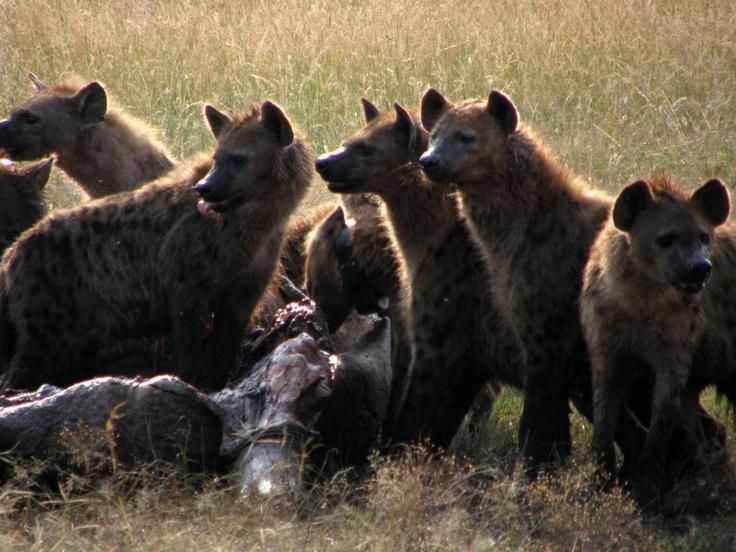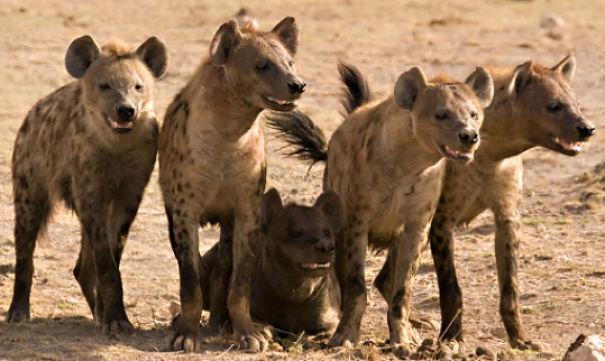The first image is the image on the left, the second image is the image on the right. Evaluate the accuracy of this statement regarding the images: "In one of the images there is a man surrounded by multiple hyenas.". Is it true? Answer yes or no. No. The first image is the image on the left, the second image is the image on the right. Examine the images to the left and right. Is the description "An image shows a man posed with three hyenas." accurate? Answer yes or no. No. 